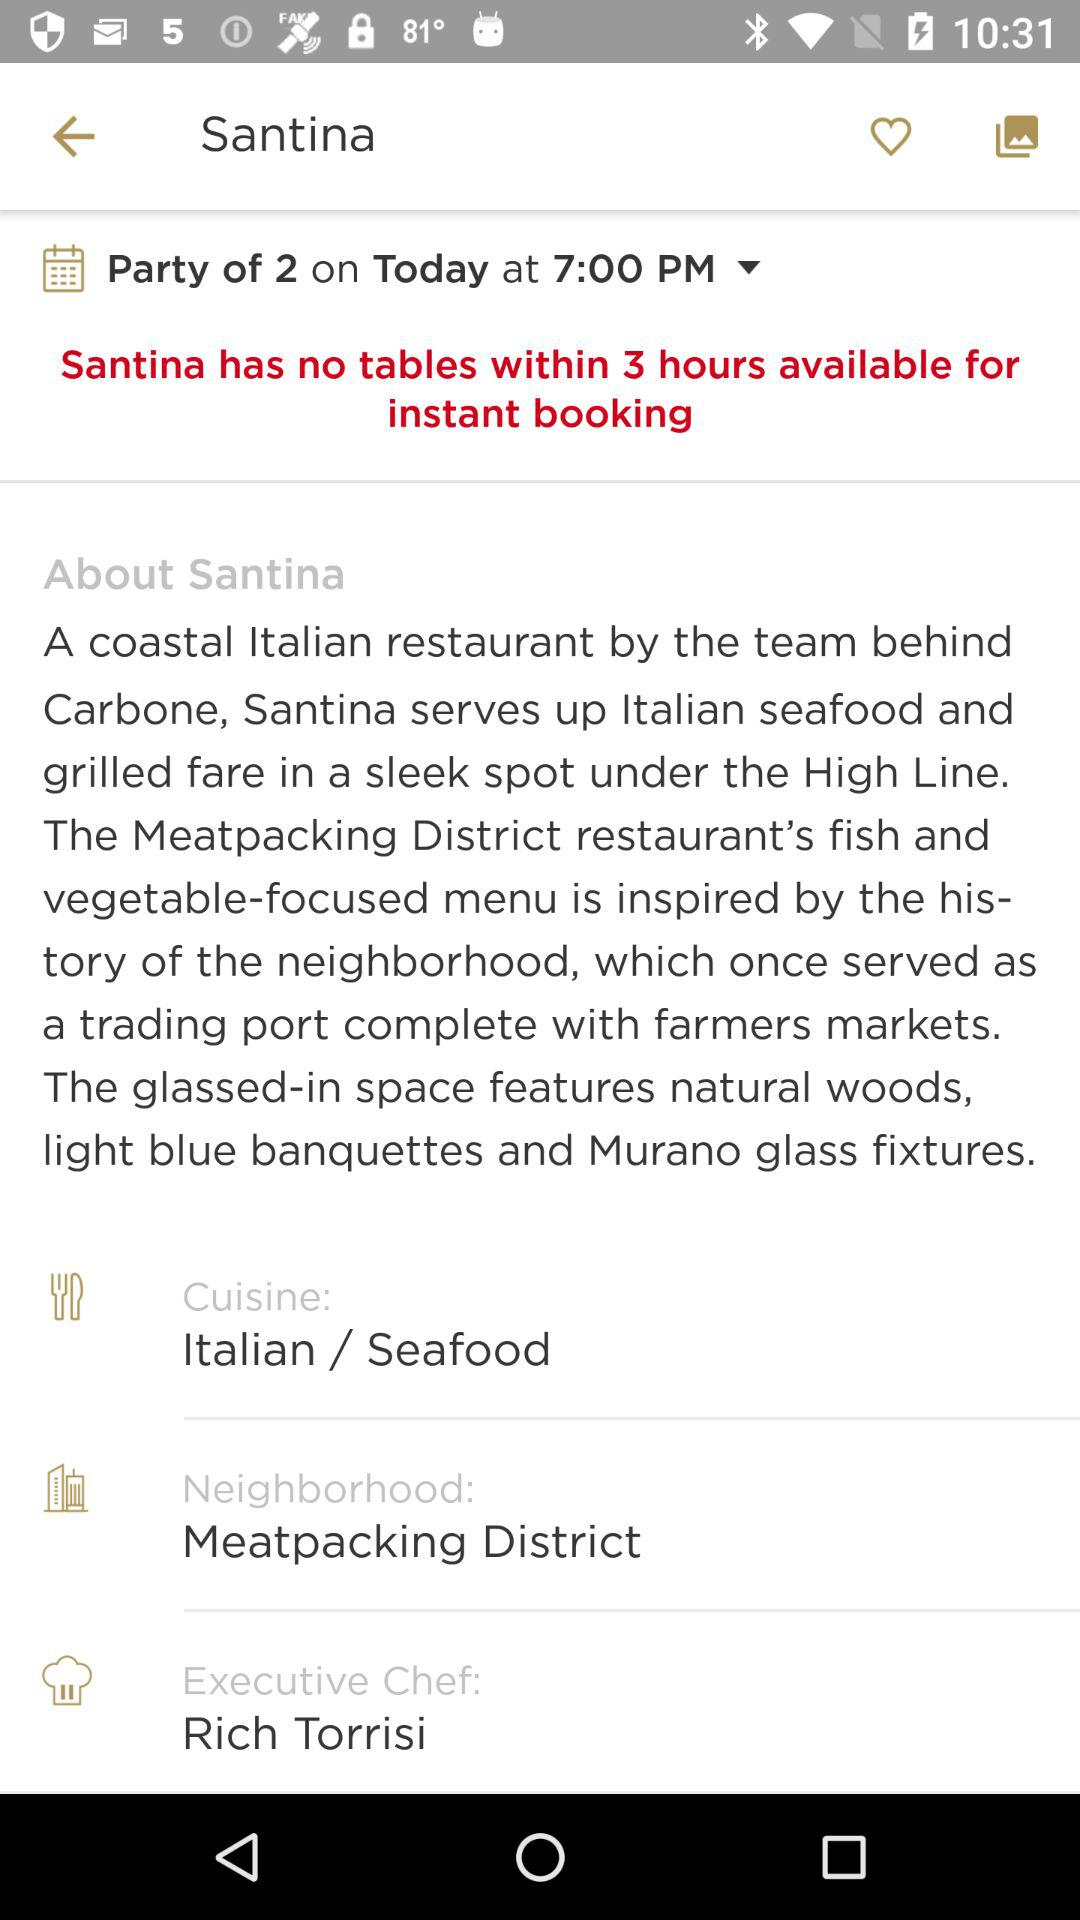For how many hours does "Santina" have no tables? "Santina" has no tables for 3 hours. 